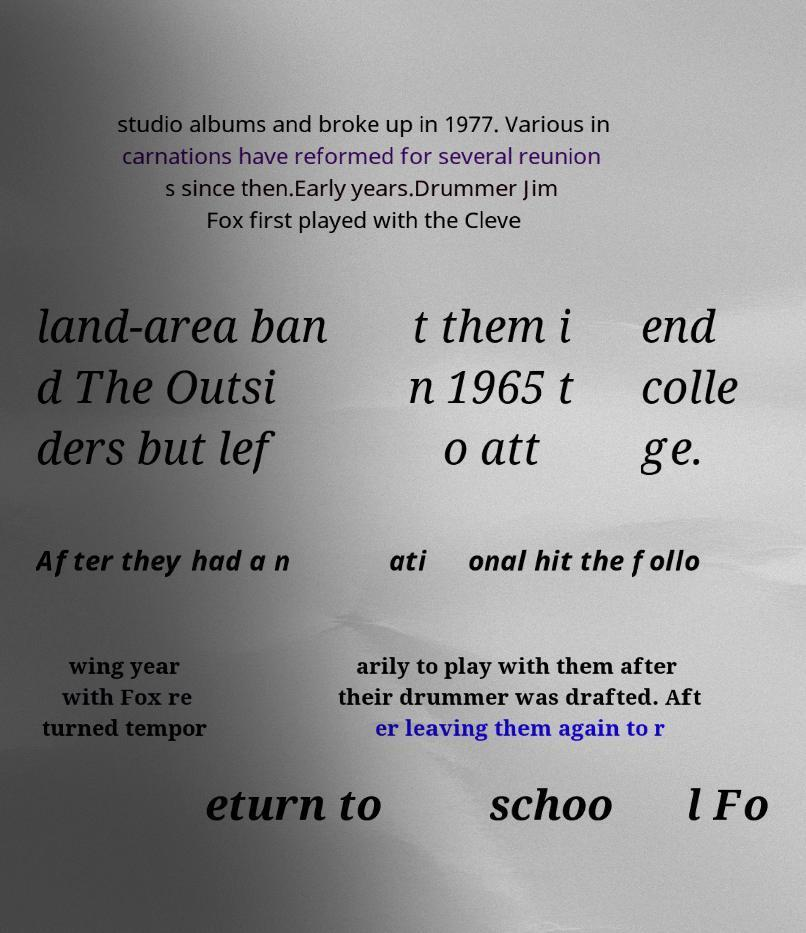Please identify and transcribe the text found in this image. studio albums and broke up in 1977. Various in carnations have reformed for several reunion s since then.Early years.Drummer Jim Fox first played with the Cleve land-area ban d The Outsi ders but lef t them i n 1965 t o att end colle ge. After they had a n ati onal hit the follo wing year with Fox re turned tempor arily to play with them after their drummer was drafted. Aft er leaving them again to r eturn to schoo l Fo 